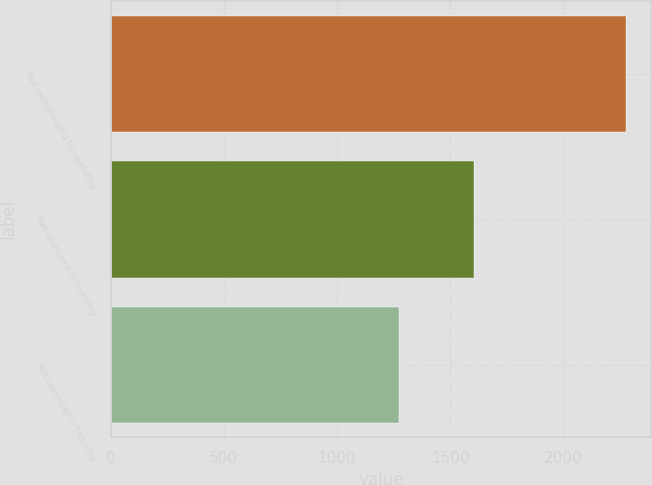<chart> <loc_0><loc_0><loc_500><loc_500><bar_chart><fcel>Net cash provided by operating<fcel>Net cash used in investing<fcel>Net cash used in financing<nl><fcel>2275<fcel>1606<fcel>1273<nl></chart> 